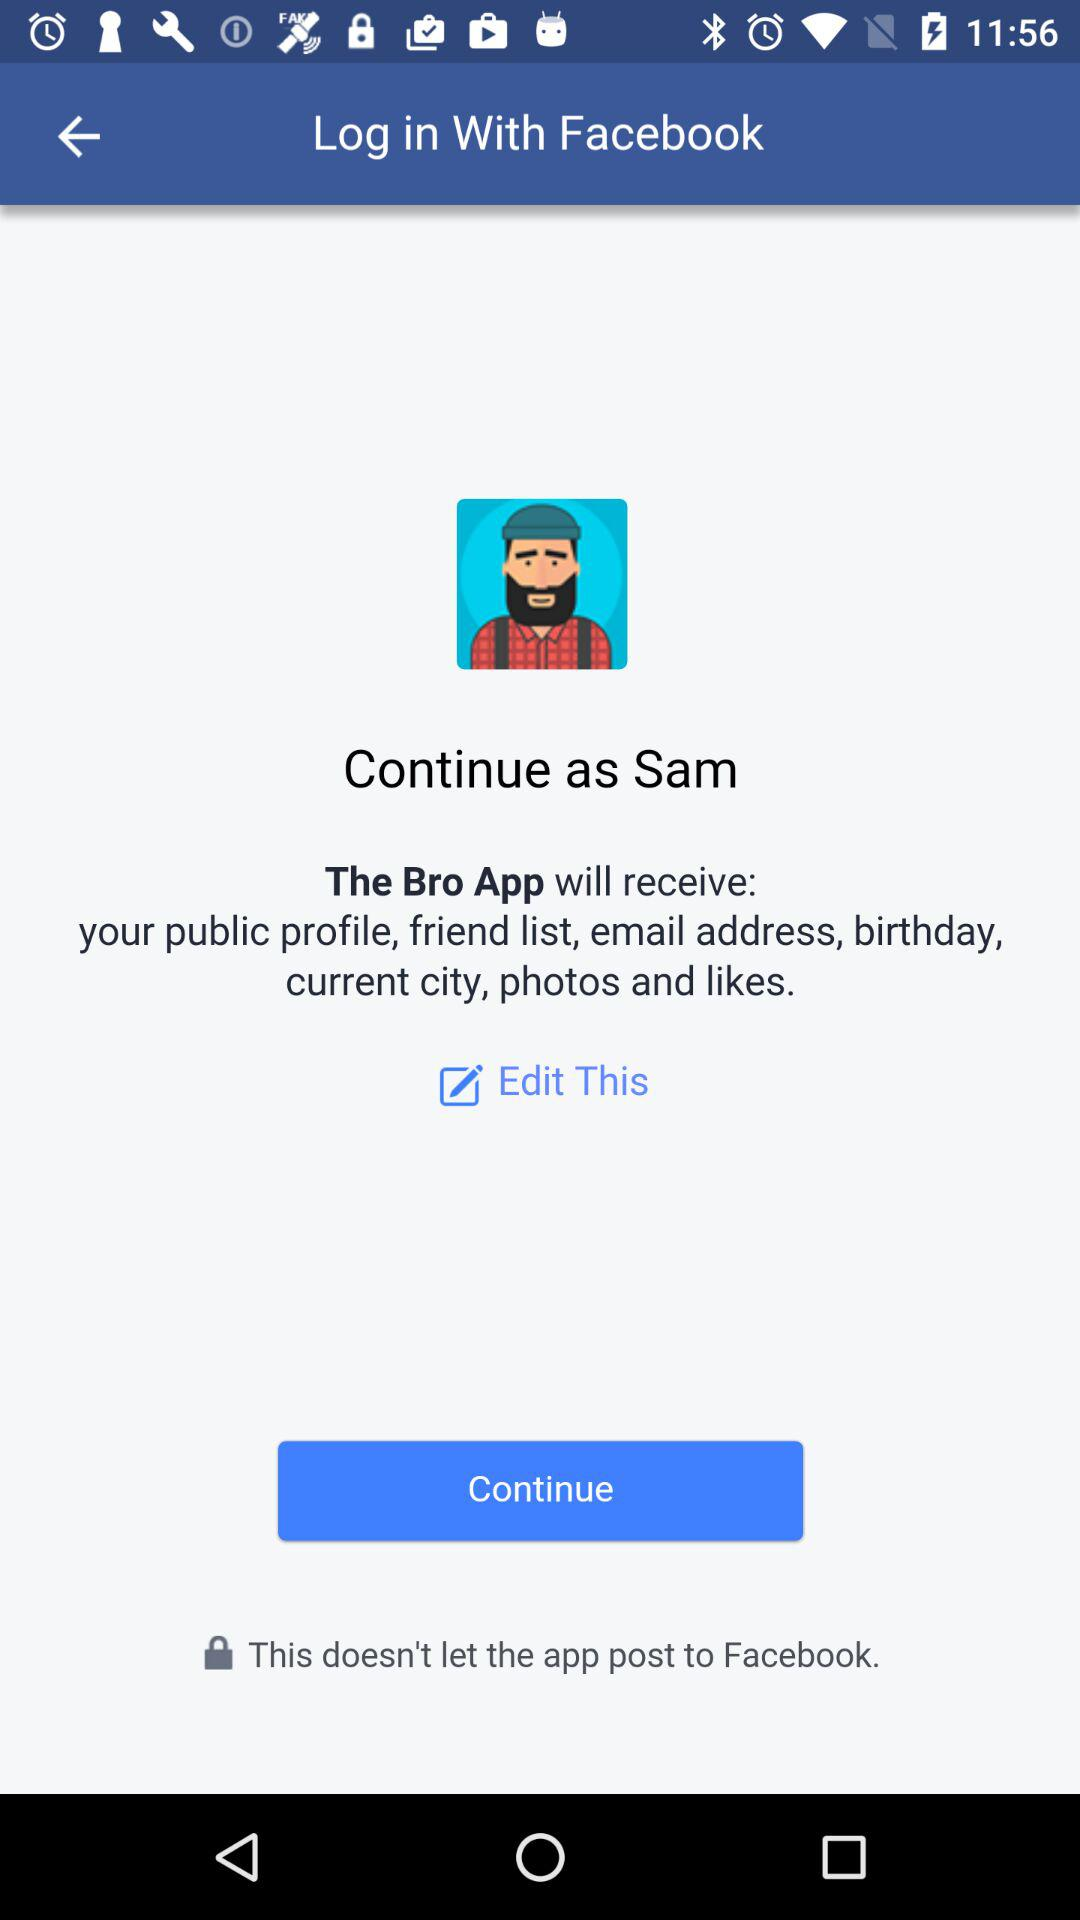Through what application can the user log in? The user can log in through "Facebook". 